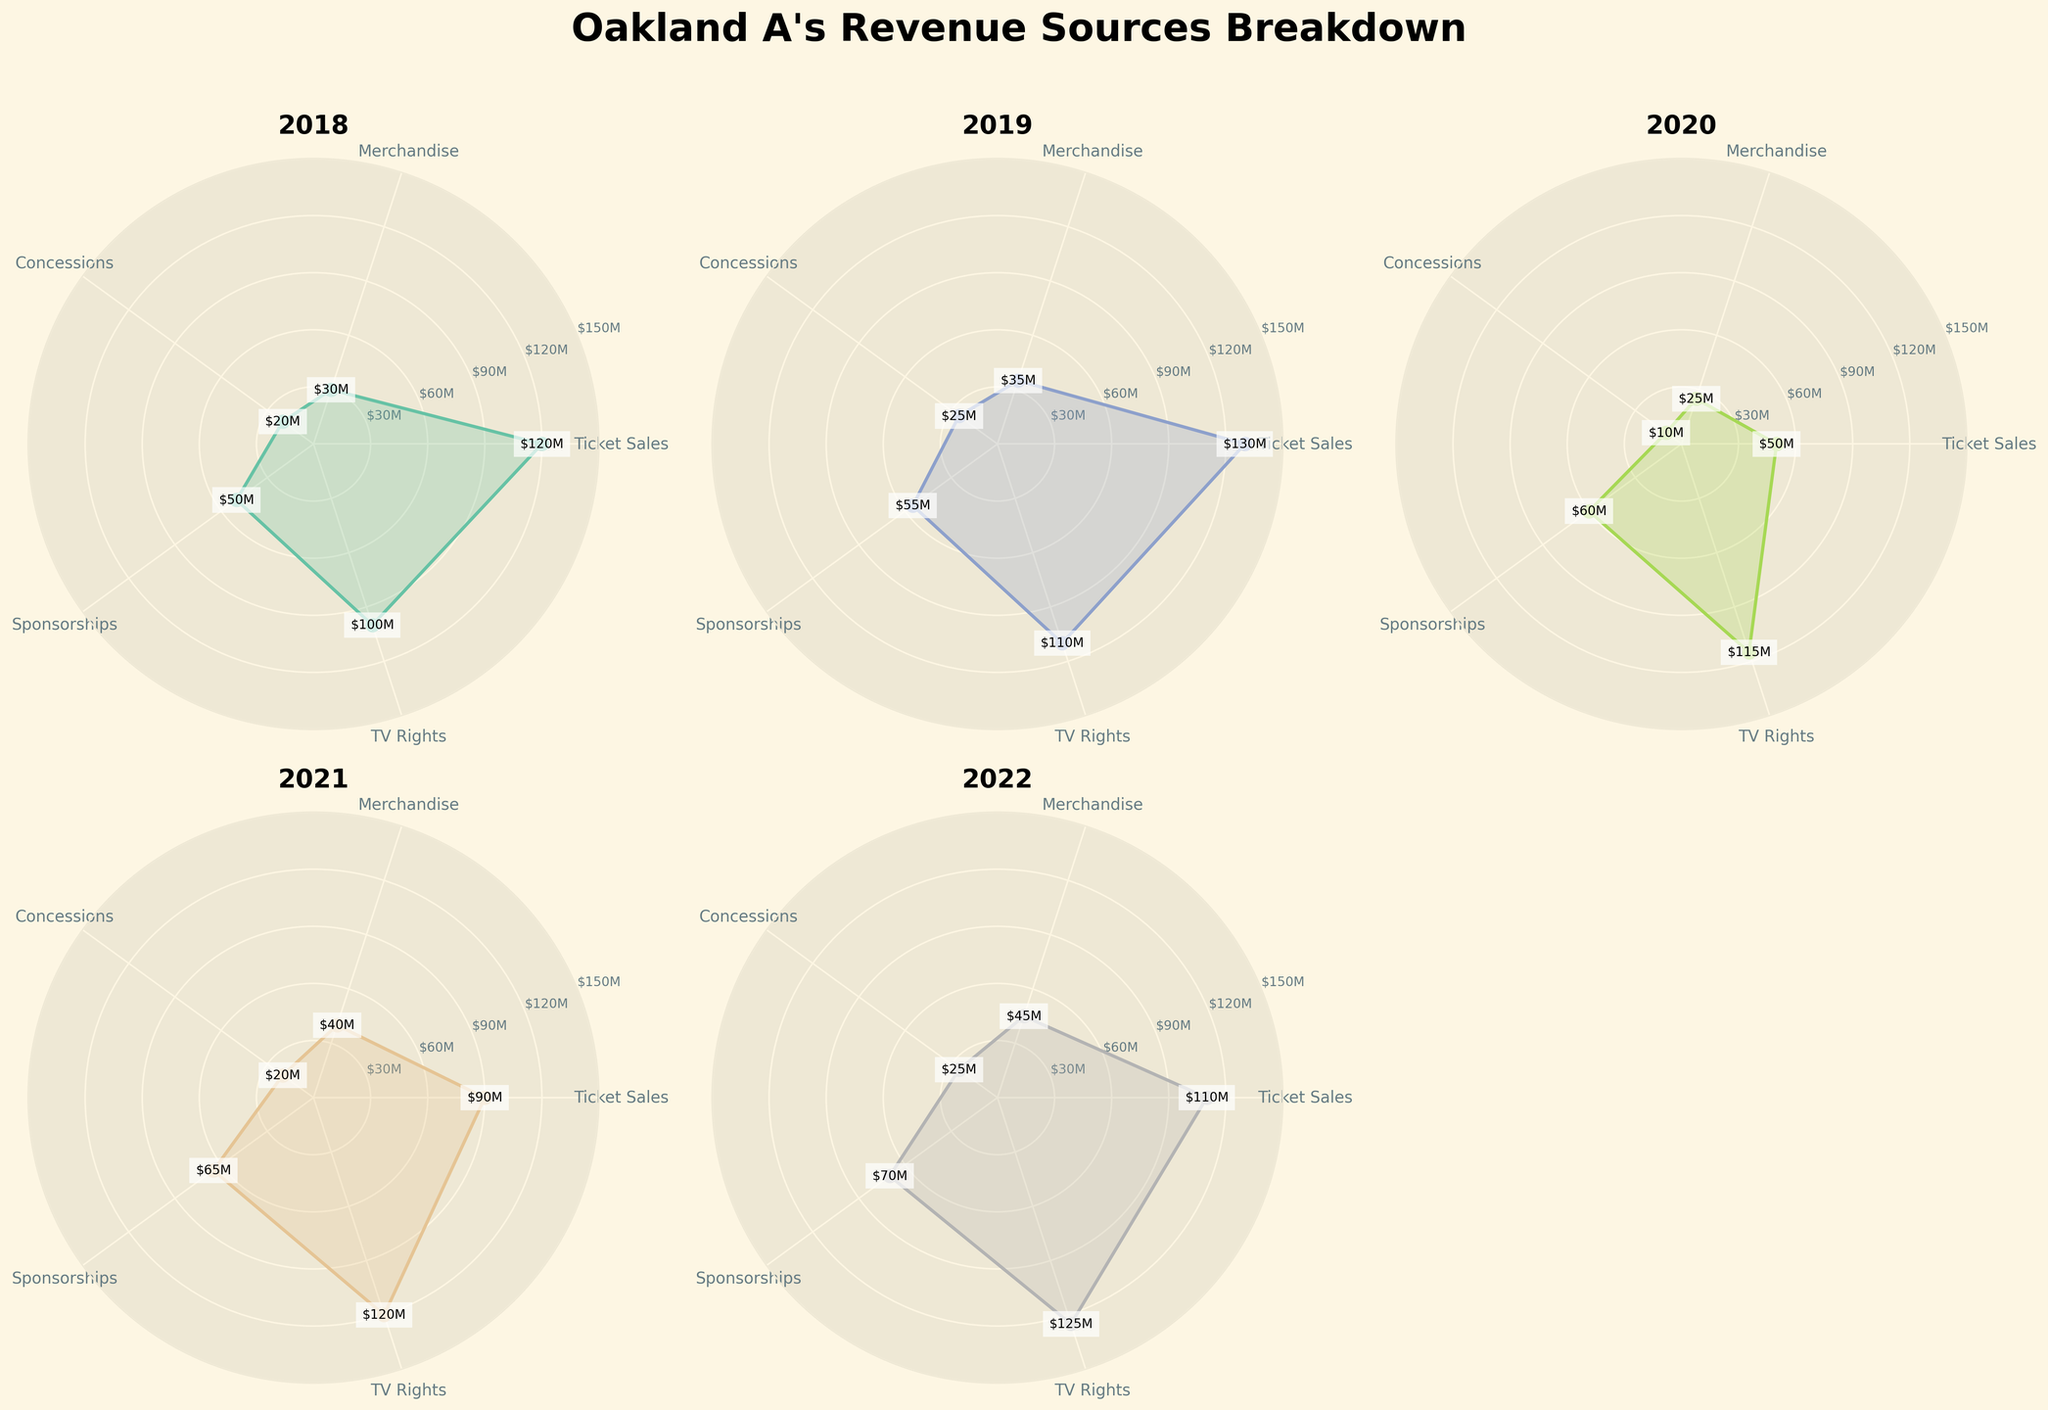What's the title of the figure? The title of the figure is displayed at the top center. The fonts are large and bold, indicating the main topic of the chart. The title clearly reads "Oakland A's Revenue Sources Breakdown".
Answer: Oakland A's Revenue Sources Breakdown Which year had the highest revenue from Ticket Sales? By looking at each subplot, find the one where the Ticket Sales data point (located at the first angle) is the highest. Compare the values for each year: 120M (2018), 130M (2019), 50M (2020), 90M (2021), and 110M (2022).
Answer: 2019 What was the total revenue from TV Rights over the entire period? Check the TV Rights values for each year (located at the fourth angle) and sum them: 100 (2018) + 110 (2019) + 115 (2020) + 120 (2021) + 125 (2022). Therefore, 570M is the total revenue from TV Rights over the five years.
Answer: 570M In which year was the revenue from Merchandise higher than the revenue from Concessions but lower than the revenue from Sponsorships? For each year, verify if the revenue from Merchandise fits between Concessions and Sponsorships. The years with this pattern are 2018: 30 > 20 < 50, 2019: 35 > 25 < 55, 2021: 40 > 20 < 65, 2022: 45 > 25 < 70.
Answer: 2018, 2019, 2021, 2022 What is the average revenue from Sponsorships over the years 2018 and 2019? Check the Sponsorships values for 2018 (50M) and 2019 (55M). The average is calculated as (50 + 55) / 2 = 52.5M.
Answer: 52.5M Which year shows the smallest value for Concessions? By checking each subplot for the value at the third angle representing Concessions, compare the values: 20 (2018), 25 (2019), 10 (2020), 20 (2021), and 25 (2022). The smallest value is 10 for the year 2020.
Answer: 2020 How much higher was the revenue from TV Rights in 2022 compared to 2018? Compare the values at the mentioned angles: 125M (2022) and 100M (2018). The difference is 125 - 100 = 25M.
Answer: 25M Which revenue source had the least variation in revenue over the 5 years? Analyze the radar plots and note the smaller range in values for each source. Concessions show the least variation with values close to each other: 20, 25, 10, 20, 25.
Answer: Concessions In what year did the Ticket Sales drop significantly, and what might have been the cause? Notice the drop in Ticket Sales from 130M (2019) to 50M (2020). 2020 was the year of the COVID-19 pandemic, likely causing the significant drop.
Answer: 2020 